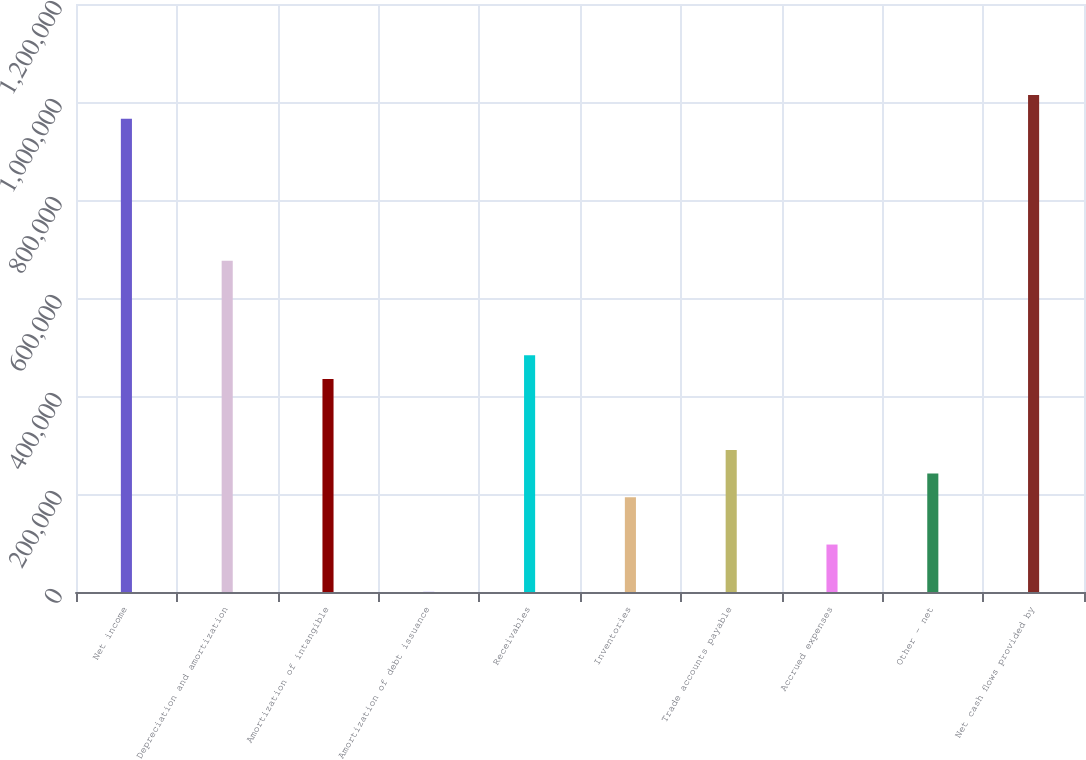<chart> <loc_0><loc_0><loc_500><loc_500><bar_chart><fcel>Net income<fcel>Depreciation and amortization<fcel>Amortization of intangible<fcel>Amortization of debt issuance<fcel>Receivables<fcel>Inventories<fcel>Trade accounts payable<fcel>Accrued expenses<fcel>Other - net<fcel>Net cash flows provided by<nl><fcel>965800<fcel>676146<fcel>434768<fcel>288<fcel>483044<fcel>193390<fcel>289942<fcel>96839.2<fcel>241666<fcel>1.01408e+06<nl></chart> 